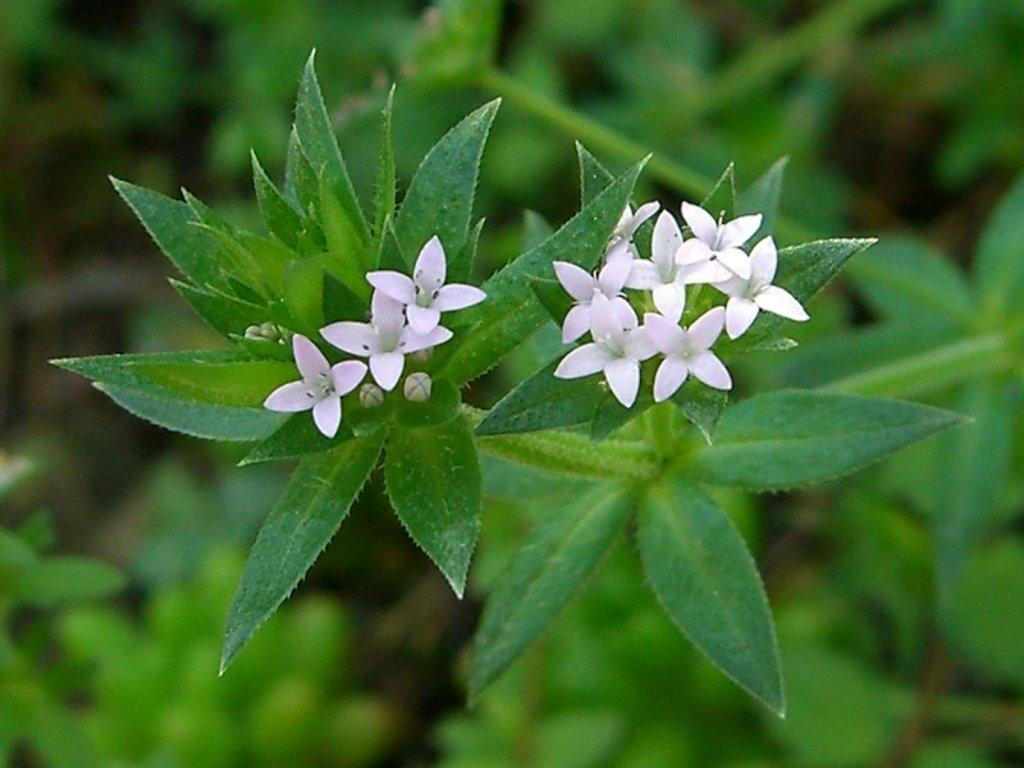What type of flowers are in the image? There are white color flowers in the image. What else can be seen in the image besides the flowers? There are leaves in the image. How would you describe the background of the image? The background of the image is blurry. What type of poison is present in the image? There is no poison present in the image; it features white color flowers and leaves. What type of secretary can be seen working in the image? There is no secretary present in the image. 